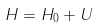Convert formula to latex. <formula><loc_0><loc_0><loc_500><loc_500>H = H _ { 0 } + U</formula> 